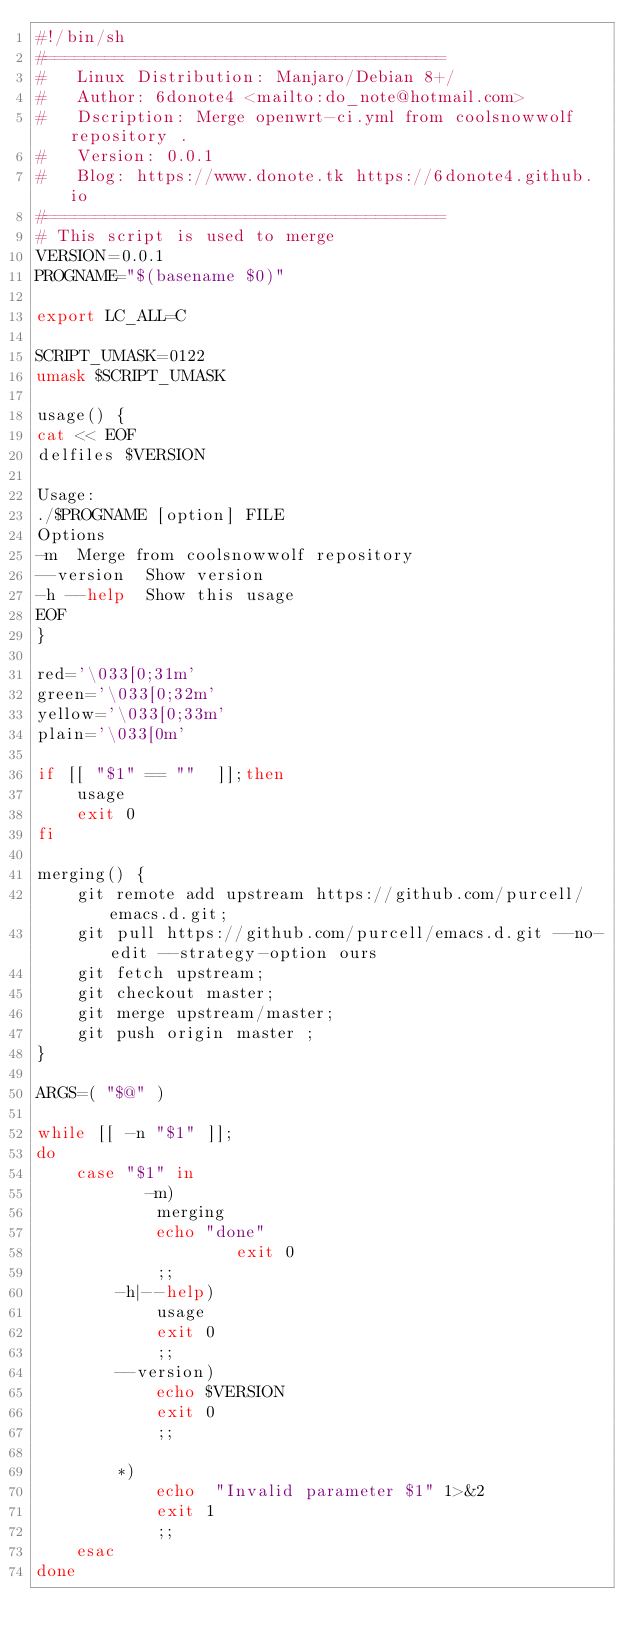<code> <loc_0><loc_0><loc_500><loc_500><_Bash_>#!/bin/sh
#========================================
#   Linux Distribution: Manjaro/Debian 8+/
#   Author: 6donote4 <mailto:do_note@hotmail.com>
#   Dscription: Merge openwrt-ci.yml from coolsnowwolf repository .
#   Version: 0.0.1
#   Blog: https://www.donote.tk https://6donote4.github.io
#========================================
# This script is used to merge
VERSION=0.0.1
PROGNAME="$(basename $0)"

export LC_ALL=C

SCRIPT_UMASK=0122
umask $SCRIPT_UMASK

usage() {
cat << EOF
delfiles $VERSION

Usage:
./$PROGNAME [option] FILE
Options
-m  Merge from coolsnowwolf repository
--version  Show version
-h --help  Show this usage
EOF
}

red='\033[0;31m'
green='\033[0;32m'
yellow='\033[0;33m'
plain='\033[0m'

if [[ "$1" == ""  ]];then
    usage
    exit 0
fi

merging() {
    git remote add upstream https://github.com/purcell/emacs.d.git;
    git pull https://github.com/purcell/emacs.d.git --no-edit --strategy-option ours
    git fetch upstream;
    git checkout master;
    git merge upstream/master;
    git push origin master ;
}

ARGS=( "$@" )

while [[ -n "$1" ]];
do
	case "$1" in
           -m)
			merging
			echo "done"
	                exit 0
			;;
	    -h|--help)
			usage
			exit 0
			;;
	    --version)
			echo $VERSION
			exit 0
			;;

	    *)
			echo  "Invalid parameter $1" 1>&2
			exit 1
			;;
	esac
done
</code> 